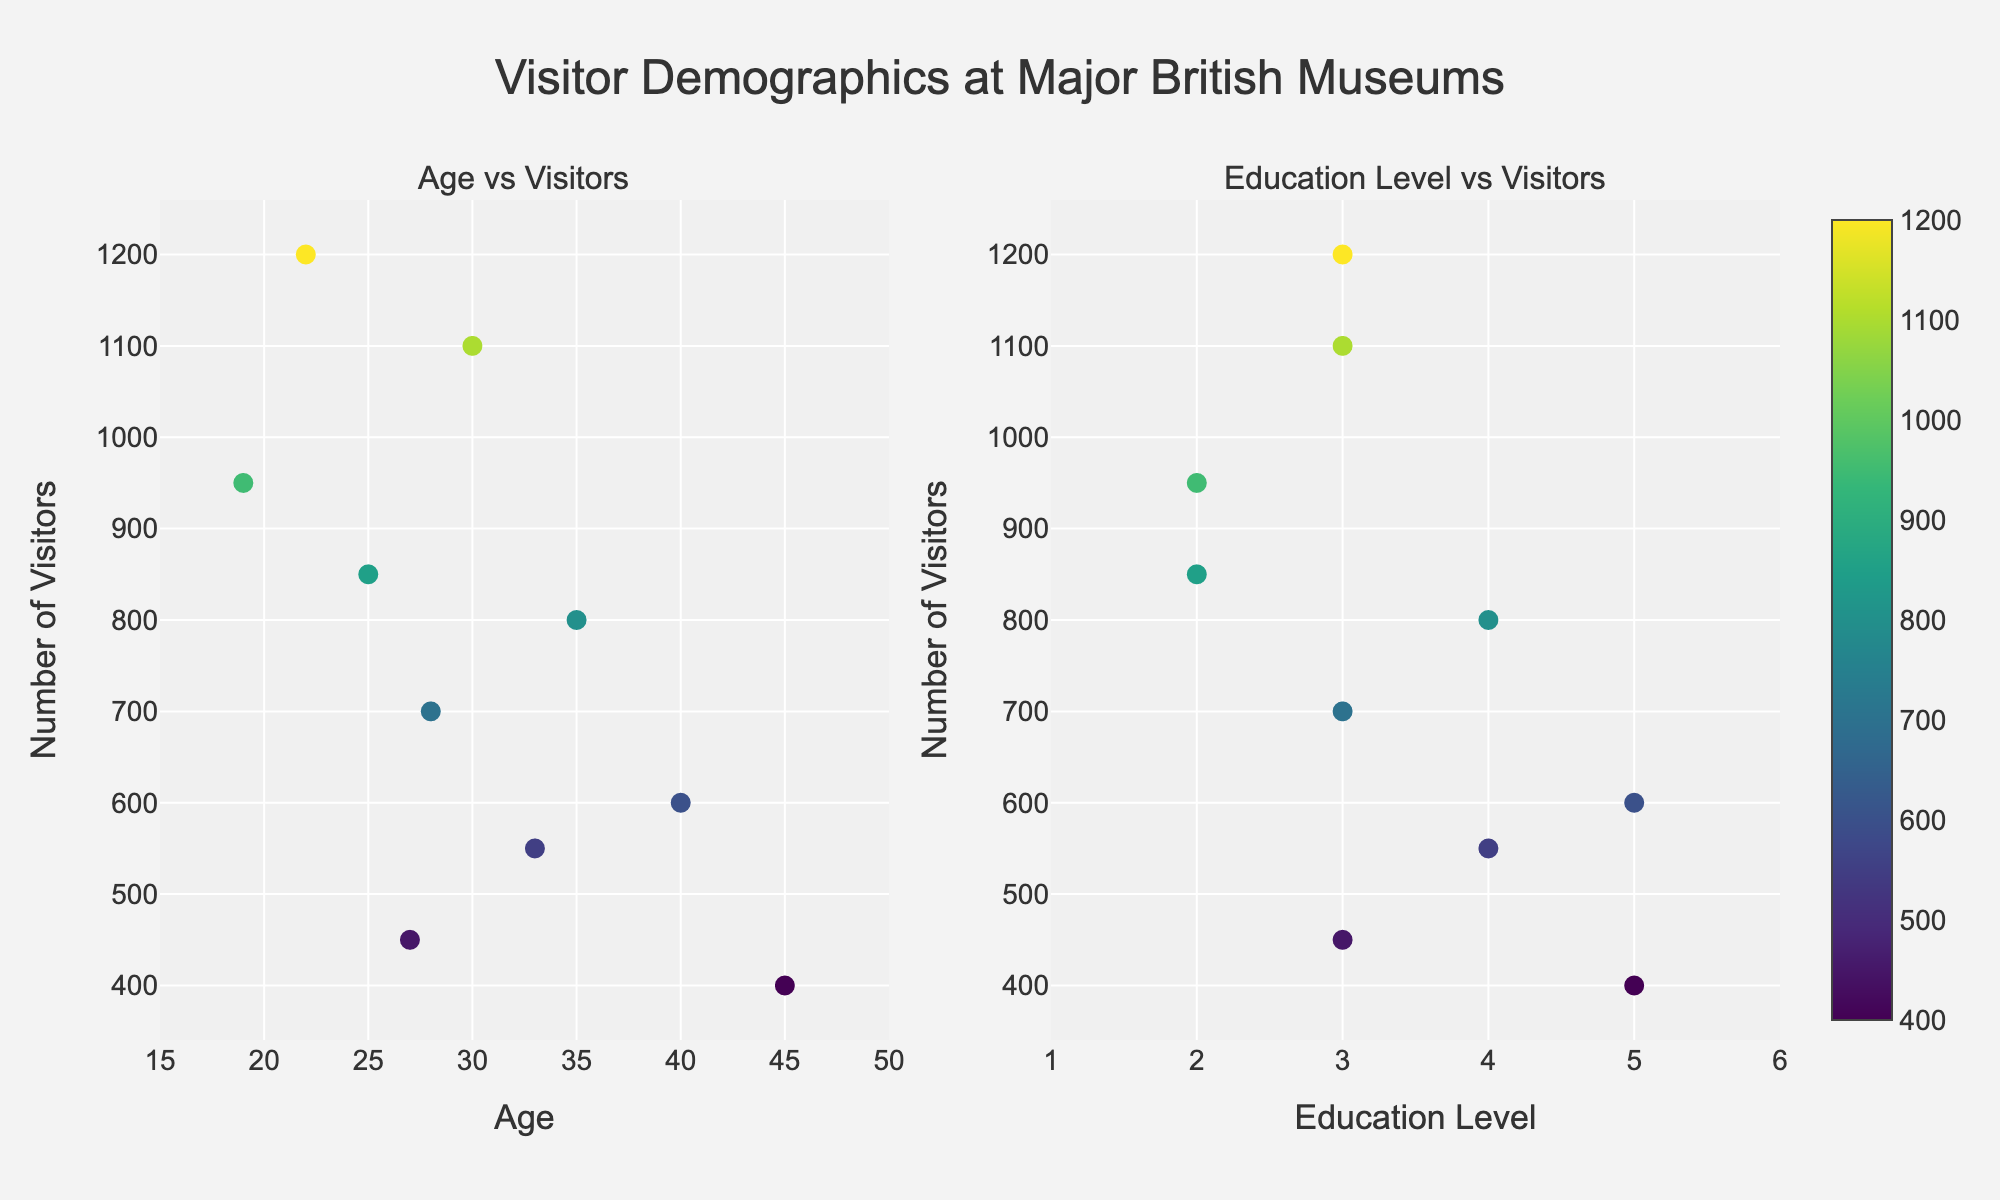How many museums have their visitor count plotted in the "Age vs Visitors" scatter plot? The "Age vs Visitors" scatter plot shows a data point for each museum listed in the provided data. We can count the number of unique museums and correspond them to the number of data points for the age-to-visitor comparison. There are 10 museums in the data list, meaning there should be 10 data points in the scatter plot.
Answer: 10 What is the title of the figure? The title of the figure is usually displayed at the top of the figure, clearly indicating the overall topic being represented.
Answer: "Visitor Demographics at Major British Museums" Which museum has the highest number of visitors, and what is the visitor count? The scatter plots provide hover information for each data point, including the museum name and visitor count. By identifying the data point with the highest y-value (number of visitors), we can find the corresponding museum and visitor count.
Answer: British Museum, 1200 What age range is displayed on the x-axis of the "Age vs Visitors" scatter plot? The x-axis range is specified in the plot settings, typically displayed with tick marks and labels. Based on the provided code, the age range should be from 15 to 50 years old.
Answer: 15-50 Which museum attracts visitors with the highest education level, based on the "Education Level vs Visitors" scatter plot? The scatter plot for "Education Level vs Visitors" includes education levels and visitor counts for each museum. The museum with the highest point on the education level axis is the one attracting visitors with the highest education level.
Answer: Ashmolean Museum What is the average number of visitors across all museums? To find the average number of visitors, add the visitor counts for all museums and divide by the number of museums. Sum of visitors = 1200 + 950 + 800 + 700 + 850 + 1100 + 600 + 550 + 450 + 400 = 7600. Dividing by the number of museums (10), we get 7600/10.
Answer: 760 Is there a museum that appears in the scatter plots with both the highest education level and the oldest age group? We check the scatter point with the highest education level (Ashmolean Museum with education level 5) and compare it with its corresponding age. The highest age group is also found by the age number (Ashmolean Museum with age 45).
Answer: Yes, Ashmolean Museum Which museum has the smallest visitor count, and how many visitors are there? This is identified by finding the lowest y-value (number of visitors) in the scatter plots. Hovering over the corresponding data point reveals the museum name and visitor count.
Answer: Ashmolean Museum, 400 